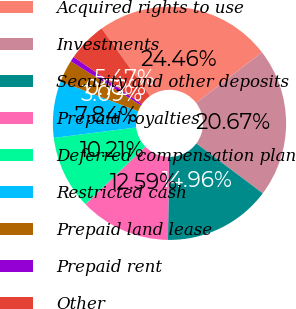<chart> <loc_0><loc_0><loc_500><loc_500><pie_chart><fcel>Acquired rights to use<fcel>Investments<fcel>Security and other deposits<fcel>Prepaid royalties<fcel>Deferred compensation plan<fcel>Restricted cash<fcel>Prepaid land lease<fcel>Prepaid rent<fcel>Other<nl><fcel>24.46%<fcel>20.67%<fcel>14.96%<fcel>12.59%<fcel>10.21%<fcel>7.84%<fcel>3.09%<fcel>0.72%<fcel>5.47%<nl></chart> 